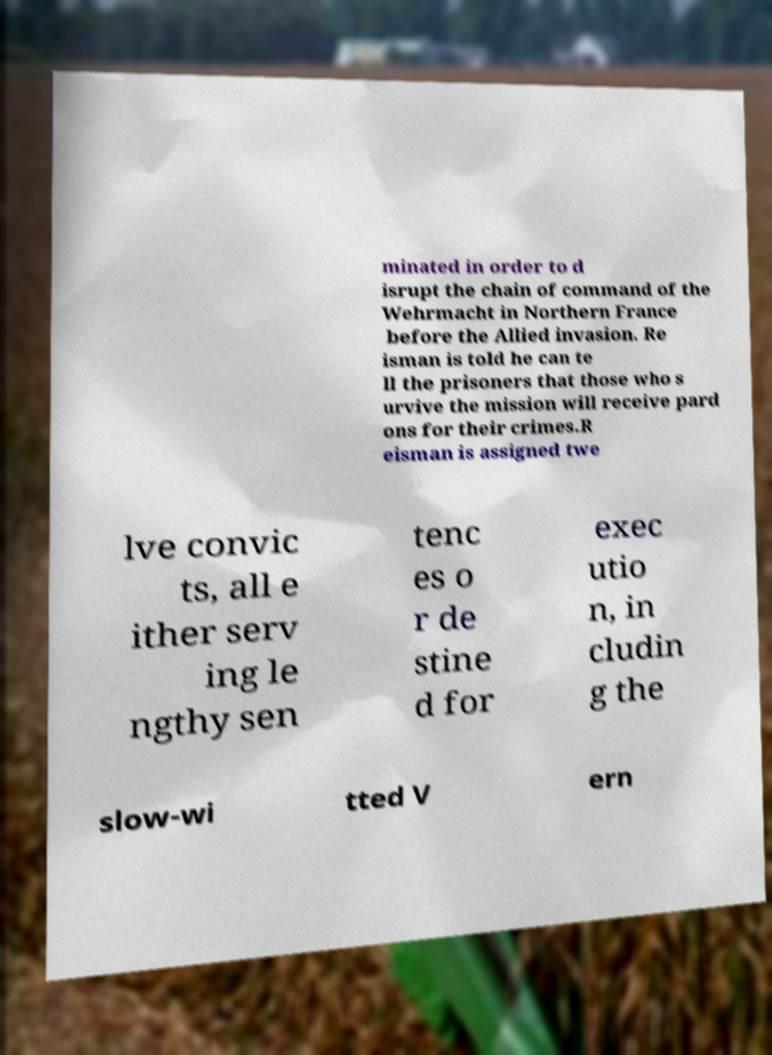What messages or text are displayed in this image? I need them in a readable, typed format. minated in order to d isrupt the chain of command of the Wehrmacht in Northern France before the Allied invasion. Re isman is told he can te ll the prisoners that those who s urvive the mission will receive pard ons for their crimes.R eisman is assigned twe lve convic ts, all e ither serv ing le ngthy sen tenc es o r de stine d for exec utio n, in cludin g the slow-wi tted V ern 